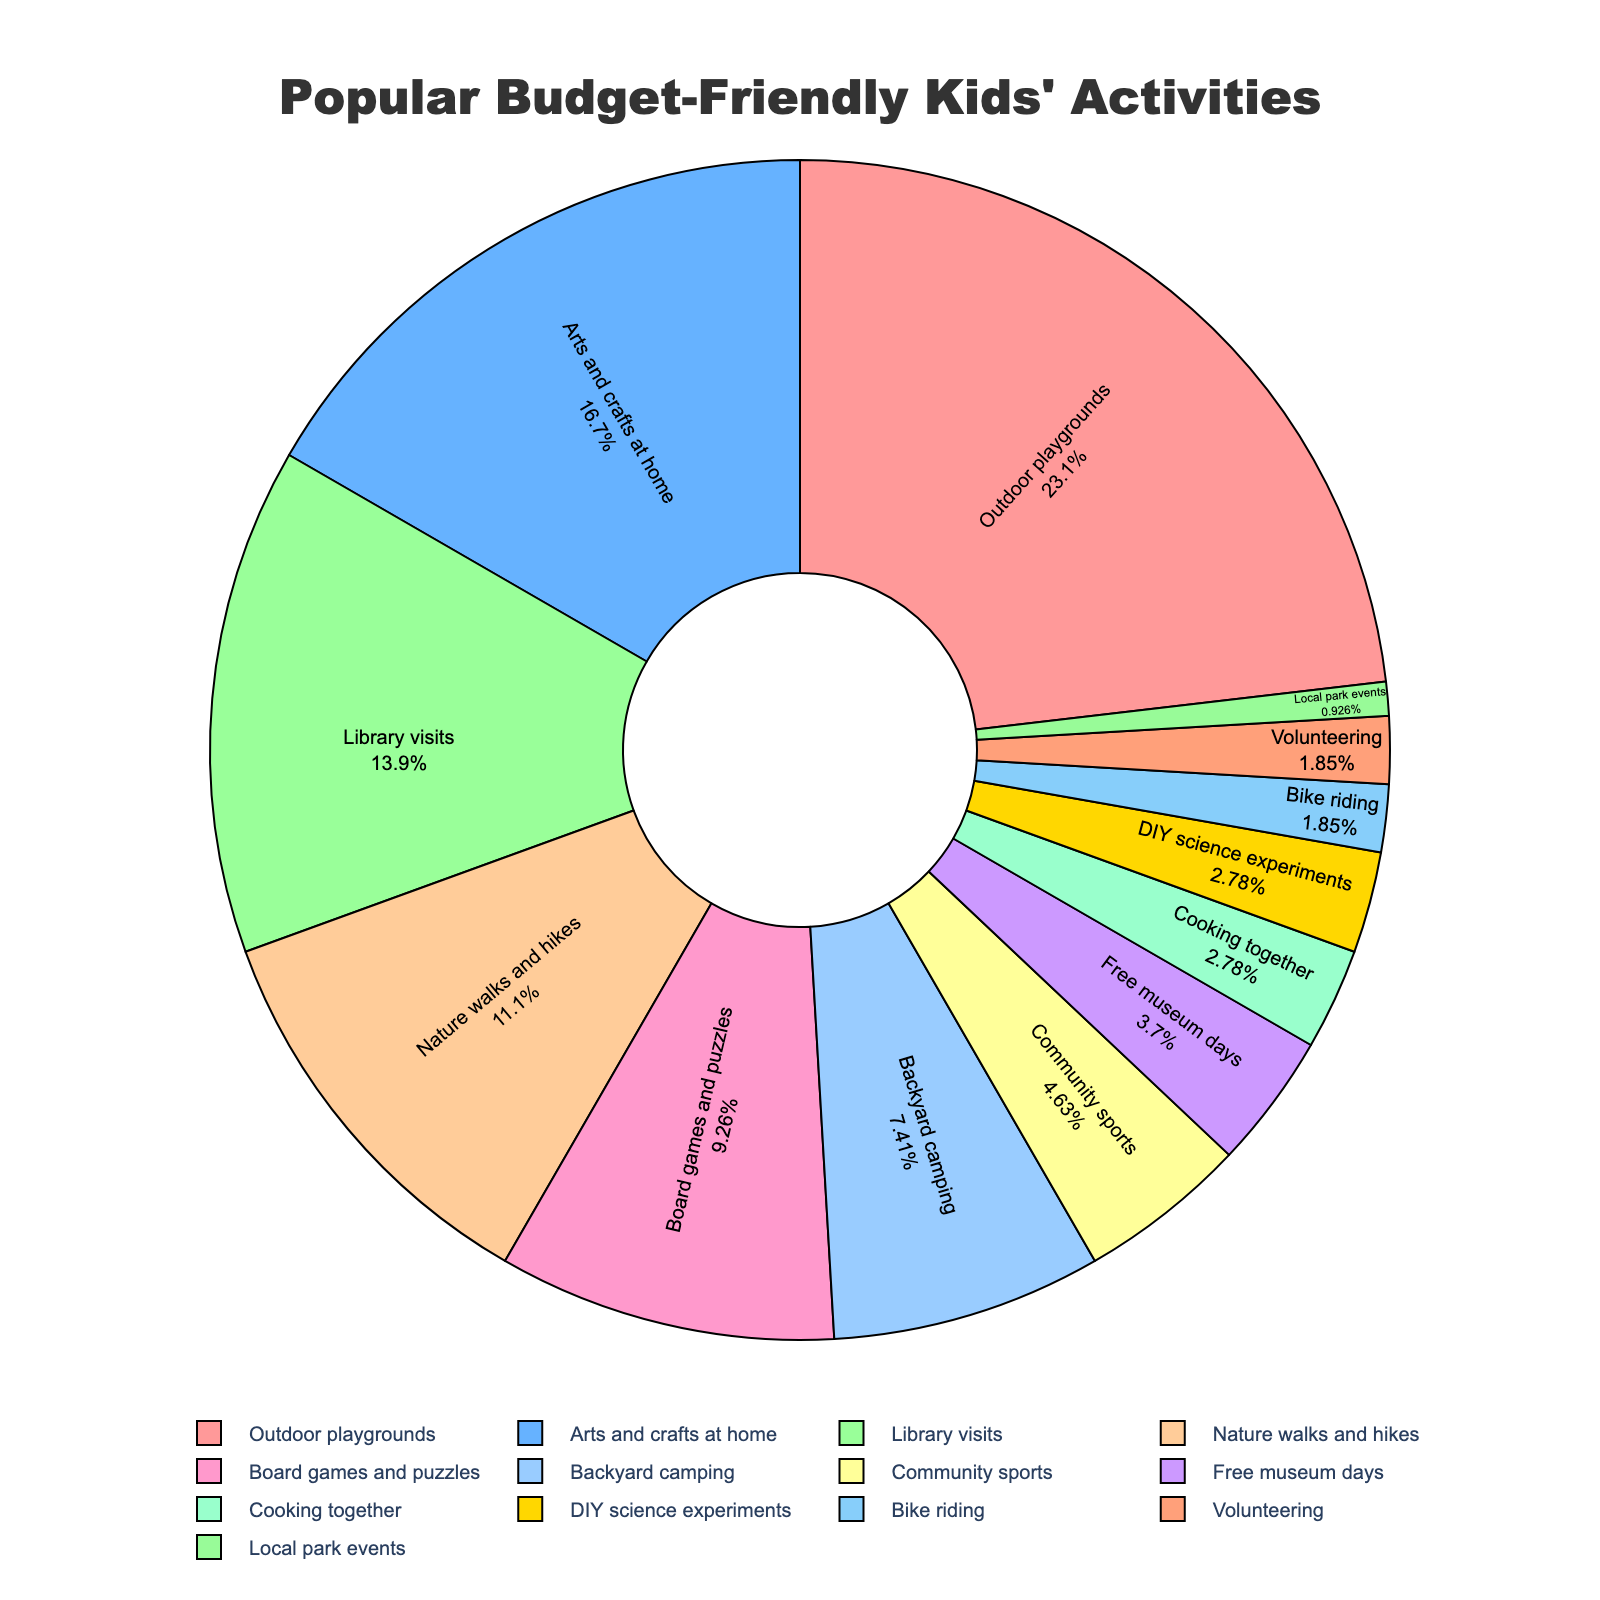Which activity has the highest percentage? The activity with the largest segment in the pie chart is the one with the highest percentage. Visually, "Outdoor playgrounds" takes up the most space in the chart with a percentage of 25%.
Answer: Outdoor playgrounds Which two activities have the lowest percentages? The smallest segments in the pie chart represent the activities with the lowest percentages. "Bike riding" and "Volunteering" both have the smallest slices, each contributing 2% to the total activities.
Answer: Bike riding and Volunteering What is the combined percentage of "Library visits" and "Nature walks and hikes"? Find "Library visits" and "Nature walks and hikes" on the pie chart and add their percentages. "Library visits" has 15% and "Nature walks and hikes" has 12%. Summing them up gives 15% + 12% = 27%.
Answer: 27% Is the percentage of "Arts and crafts at home" greater than that of "Board games and puzzles"? Compare the sizes of the segments for these two activities. "Arts and crafts at home" have a larger slice at 18%, while "Board games and puzzles" have a smaller slice at 10%.
Answer: Yes Which activities have a percentage of 3% each? Look for segments labeled with 3% in the pie chart. "Cooking together" and "DIY science experiments" are the activities that each take up 3% of the pie chart.
Answer: Cooking together and DIY science experiments What is the difference in percentages between "Community sports" and "Free museum days"? Find the segments for these two activities and subtract the smaller percentage from the larger one. "Community sports" has 5% and "Free museum days" has 4%, so the difference is 5% - 4% = 1%.
Answer: 1% What is the total percentage of the top three activities? Identify the top three activities by size and sum their percentages. "Outdoor playgrounds" is 25%, "Arts and crafts at home" is 18%, and "Library visits" is 15%. The total is 25% + 18% + 15% = 58%.
Answer: 58% Which activity uses green color in the pie chart? Observe the color distribution in the pie chart and identify the green-colored segment. "Arts and crafts at home" is represented with a green color.
Answer: Arts and crafts at home What is the average percentage of activities with more than 10%? Identify activities with percentages greater than 10% and calculate their average. These activities are "Outdoor playgrounds" (25%), "Arts and crafts at home" (18%), "Library visits" (15%), and "Nature walks and hikes" (12%). Calculate the average: (25% + 18% + 15% + 12%) / 4 = 17.5%.
Answer: 17.5% Which activity has a percentage closest to the average percentage of all activities? Calculate the average of all percentages and find the activity closest to this value. Summing all percentages gives 100%, and there are 13 activities, so the average is 100% / 13 ≈ 7.7%. "Backyard camping" with 8% is closest to this average.
Answer: Backyard camping 